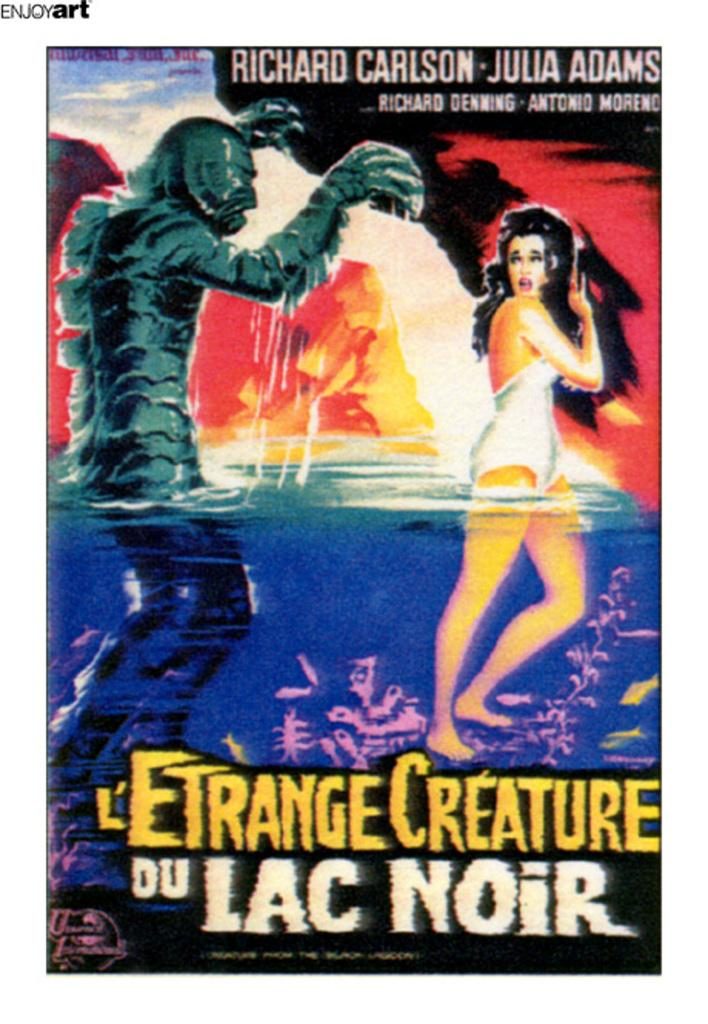<image>
Describe the image concisely. Julia Adams stars in this film called L"Etrange Creature. 